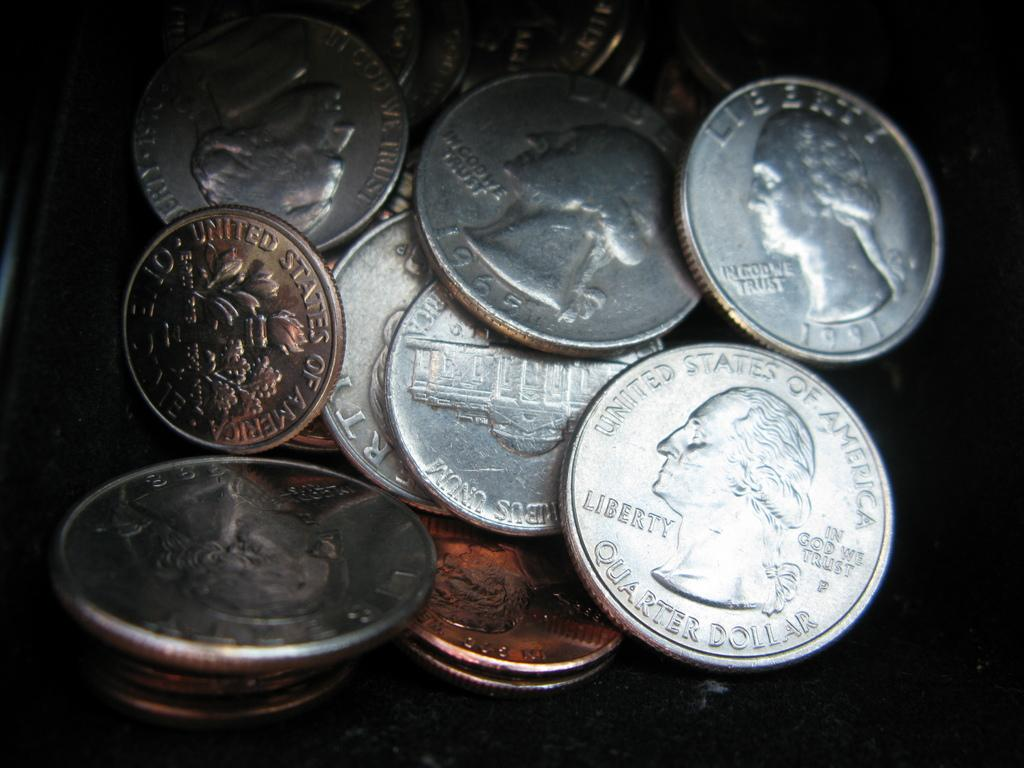<image>
Present a compact description of the photo's key features. A variety of U.S. currencies in a pile which includes a penny, nickel, dime and quarter. 